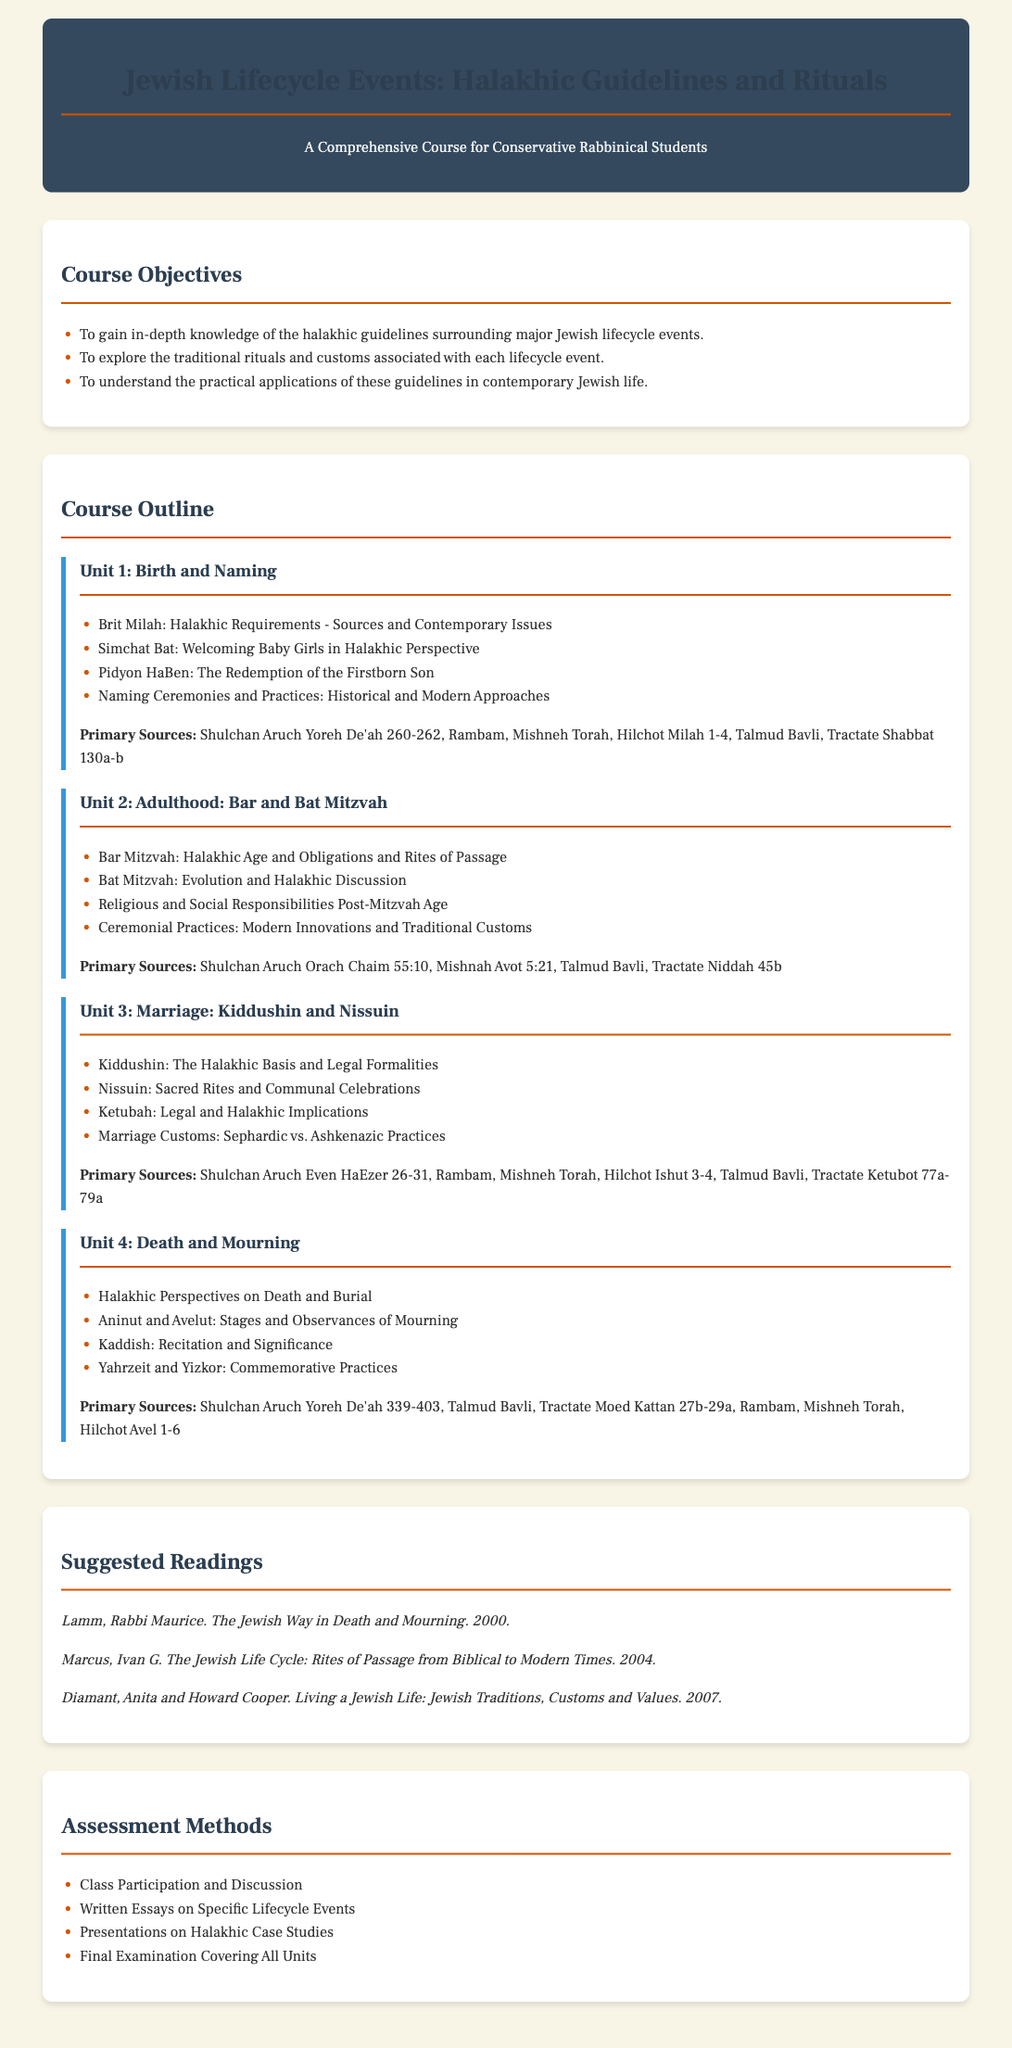what is the title of the syllabus? The title of the syllabus is explicitly stated at the beginning of the document.
Answer: Jewish Lifecycle Events: Halakhic Guidelines and Rituals who is the intended audience for this course? The intended audience is mentioned in the title of the syllabus.
Answer: Conservative Rabbinical Students how many units are included in the course outline? The document outlines a specific number of units, each corresponding to a lifecycle event.
Answer: Four what is the primary source mentioned for Unit 1? Each unit lists primary sources as a reference for halakhic guidelines.
Answer: Shulchan Aruch Yoreh De'ah 260-262 what topic does Unit 3 cover? Each unit is titled to indicate the lifecycle event it discusses.
Answer: Marriage: Kiddushin and Nissuin which reading was published in 2000? The publication year of the suggested readings is provided in the document.
Answer: The Jewish Way in Death and Mourning what are the main assessment methods listed? The assessment section of the syllabus lists various methods.
Answer: Class Participation and Discussion what is the focus of Unit 4? Each unit has a specific focus related to lifecycle events.
Answer: Death and Mourning how many suggested readings are listed in the syllabus? The number of suggested readings is explicitly stated in the readings section.
Answer: Three 